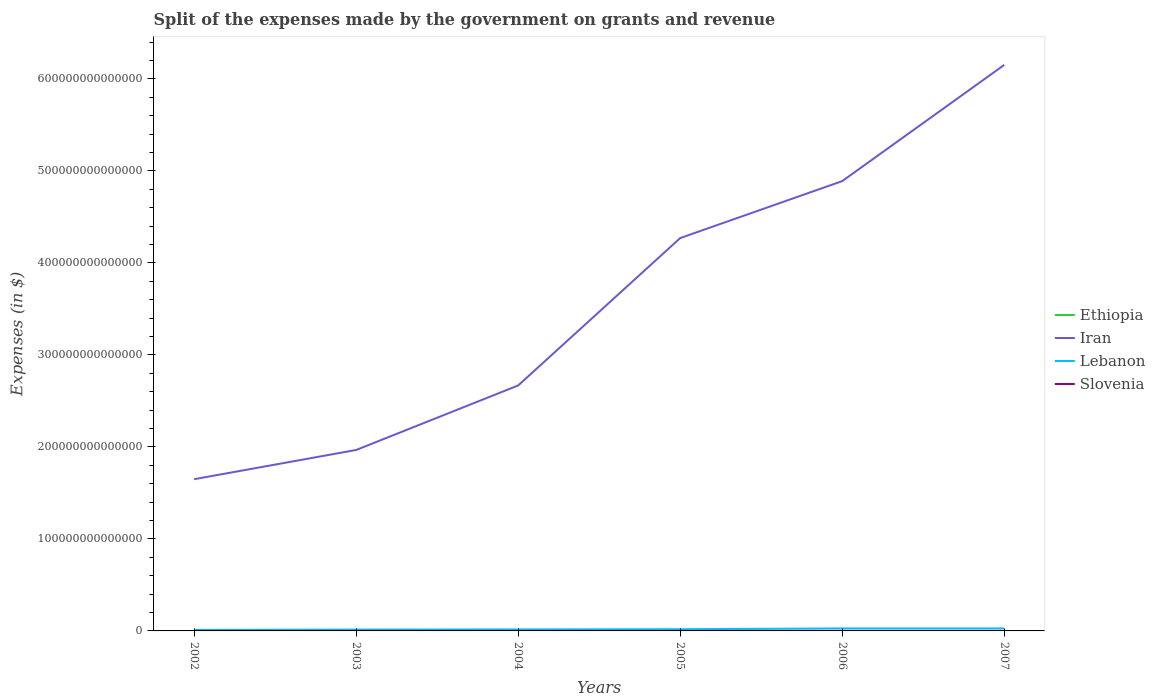Across all years, what is the maximum expenses made by the government on grants and revenue in Ethiopia?
Offer a very short reply. 2.69e+09. What is the total expenses made by the government on grants and revenue in Iran in the graph?
Offer a terse response. -2.62e+14. What is the difference between the highest and the second highest expenses made by the government on grants and revenue in Lebanon?
Your response must be concise. 1.57e+12. What is the difference between the highest and the lowest expenses made by the government on grants and revenue in Iran?
Provide a succinct answer. 3. Is the expenses made by the government on grants and revenue in Ethiopia strictly greater than the expenses made by the government on grants and revenue in Lebanon over the years?
Give a very brief answer. Yes. How many lines are there?
Keep it short and to the point. 4. What is the difference between two consecutive major ticks on the Y-axis?
Provide a short and direct response. 1.00e+14. Does the graph contain any zero values?
Your response must be concise. No. How are the legend labels stacked?
Keep it short and to the point. Vertical. What is the title of the graph?
Offer a very short reply. Split of the expenses made by the government on grants and revenue. What is the label or title of the Y-axis?
Make the answer very short. Expenses (in $). What is the Expenses (in $) in Ethiopia in 2002?
Ensure brevity in your answer.  3.36e+09. What is the Expenses (in $) of Iran in 2002?
Provide a short and direct response. 1.65e+14. What is the Expenses (in $) of Lebanon in 2002?
Your answer should be very brief. 1.14e+12. What is the Expenses (in $) in Slovenia in 2002?
Ensure brevity in your answer.  8.19e+08. What is the Expenses (in $) of Ethiopia in 2003?
Offer a terse response. 4.88e+09. What is the Expenses (in $) in Iran in 2003?
Provide a succinct answer. 1.97e+14. What is the Expenses (in $) of Lebanon in 2003?
Your answer should be very brief. 1.45e+12. What is the Expenses (in $) in Slovenia in 2003?
Provide a short and direct response. 8.59e+08. What is the Expenses (in $) in Ethiopia in 2004?
Offer a terse response. 7.63e+09. What is the Expenses (in $) of Iran in 2004?
Provide a succinct answer. 2.67e+14. What is the Expenses (in $) of Lebanon in 2004?
Your answer should be compact. 1.65e+12. What is the Expenses (in $) of Slovenia in 2004?
Offer a terse response. 1.04e+09. What is the Expenses (in $) of Ethiopia in 2005?
Offer a terse response. 7.71e+09. What is the Expenses (in $) of Iran in 2005?
Ensure brevity in your answer.  4.27e+14. What is the Expenses (in $) of Lebanon in 2005?
Give a very brief answer. 1.85e+12. What is the Expenses (in $) of Slovenia in 2005?
Give a very brief answer. 1.15e+09. What is the Expenses (in $) in Ethiopia in 2006?
Your answer should be compact. 2.69e+09. What is the Expenses (in $) in Iran in 2006?
Provide a succinct answer. 4.89e+14. What is the Expenses (in $) of Lebanon in 2006?
Ensure brevity in your answer.  2.71e+12. What is the Expenses (in $) in Slovenia in 2006?
Offer a terse response. 1.16e+09. What is the Expenses (in $) in Ethiopia in 2007?
Ensure brevity in your answer.  3.34e+09. What is the Expenses (in $) in Iran in 2007?
Provide a succinct answer. 6.15e+14. What is the Expenses (in $) of Lebanon in 2007?
Make the answer very short. 2.72e+12. What is the Expenses (in $) of Slovenia in 2007?
Provide a short and direct response. 1.28e+09. Across all years, what is the maximum Expenses (in $) of Ethiopia?
Offer a very short reply. 7.71e+09. Across all years, what is the maximum Expenses (in $) in Iran?
Offer a very short reply. 6.15e+14. Across all years, what is the maximum Expenses (in $) in Lebanon?
Offer a terse response. 2.72e+12. Across all years, what is the maximum Expenses (in $) of Slovenia?
Offer a terse response. 1.28e+09. Across all years, what is the minimum Expenses (in $) of Ethiopia?
Make the answer very short. 2.69e+09. Across all years, what is the minimum Expenses (in $) in Iran?
Provide a succinct answer. 1.65e+14. Across all years, what is the minimum Expenses (in $) in Lebanon?
Your answer should be very brief. 1.14e+12. Across all years, what is the minimum Expenses (in $) of Slovenia?
Give a very brief answer. 8.19e+08. What is the total Expenses (in $) of Ethiopia in the graph?
Keep it short and to the point. 2.96e+1. What is the total Expenses (in $) of Iran in the graph?
Keep it short and to the point. 2.16e+15. What is the total Expenses (in $) in Lebanon in the graph?
Provide a succinct answer. 1.15e+13. What is the total Expenses (in $) in Slovenia in the graph?
Your answer should be compact. 6.30e+09. What is the difference between the Expenses (in $) in Ethiopia in 2002 and that in 2003?
Keep it short and to the point. -1.51e+09. What is the difference between the Expenses (in $) of Iran in 2002 and that in 2003?
Keep it short and to the point. -3.18e+13. What is the difference between the Expenses (in $) of Lebanon in 2002 and that in 2003?
Keep it short and to the point. -3.08e+11. What is the difference between the Expenses (in $) in Slovenia in 2002 and that in 2003?
Provide a short and direct response. -3.99e+07. What is the difference between the Expenses (in $) of Ethiopia in 2002 and that in 2004?
Your answer should be very brief. -4.27e+09. What is the difference between the Expenses (in $) of Iran in 2002 and that in 2004?
Make the answer very short. -1.02e+14. What is the difference between the Expenses (in $) of Lebanon in 2002 and that in 2004?
Make the answer very short. -5.04e+11. What is the difference between the Expenses (in $) in Slovenia in 2002 and that in 2004?
Provide a succinct answer. -2.19e+08. What is the difference between the Expenses (in $) in Ethiopia in 2002 and that in 2005?
Make the answer very short. -4.35e+09. What is the difference between the Expenses (in $) in Iran in 2002 and that in 2005?
Your answer should be compact. -2.62e+14. What is the difference between the Expenses (in $) of Lebanon in 2002 and that in 2005?
Provide a succinct answer. -7.08e+11. What is the difference between the Expenses (in $) in Slovenia in 2002 and that in 2005?
Offer a very short reply. -3.29e+08. What is the difference between the Expenses (in $) of Ethiopia in 2002 and that in 2006?
Your answer should be compact. 6.76e+08. What is the difference between the Expenses (in $) of Iran in 2002 and that in 2006?
Make the answer very short. -3.24e+14. What is the difference between the Expenses (in $) in Lebanon in 2002 and that in 2006?
Your response must be concise. -1.57e+12. What is the difference between the Expenses (in $) of Slovenia in 2002 and that in 2006?
Your response must be concise. -3.39e+08. What is the difference between the Expenses (in $) in Ethiopia in 2002 and that in 2007?
Ensure brevity in your answer.  2.33e+07. What is the difference between the Expenses (in $) in Iran in 2002 and that in 2007?
Offer a very short reply. -4.50e+14. What is the difference between the Expenses (in $) in Lebanon in 2002 and that in 2007?
Your response must be concise. -1.57e+12. What is the difference between the Expenses (in $) of Slovenia in 2002 and that in 2007?
Make the answer very short. -4.64e+08. What is the difference between the Expenses (in $) of Ethiopia in 2003 and that in 2004?
Provide a succinct answer. -2.76e+09. What is the difference between the Expenses (in $) of Iran in 2003 and that in 2004?
Keep it short and to the point. -7.01e+13. What is the difference between the Expenses (in $) in Lebanon in 2003 and that in 2004?
Provide a succinct answer. -1.96e+11. What is the difference between the Expenses (in $) of Slovenia in 2003 and that in 2004?
Provide a succinct answer. -1.79e+08. What is the difference between the Expenses (in $) in Ethiopia in 2003 and that in 2005?
Keep it short and to the point. -2.84e+09. What is the difference between the Expenses (in $) in Iran in 2003 and that in 2005?
Make the answer very short. -2.30e+14. What is the difference between the Expenses (in $) of Lebanon in 2003 and that in 2005?
Give a very brief answer. -4.00e+11. What is the difference between the Expenses (in $) in Slovenia in 2003 and that in 2005?
Your response must be concise. -2.90e+08. What is the difference between the Expenses (in $) of Ethiopia in 2003 and that in 2006?
Ensure brevity in your answer.  2.19e+09. What is the difference between the Expenses (in $) in Iran in 2003 and that in 2006?
Give a very brief answer. -2.92e+14. What is the difference between the Expenses (in $) in Lebanon in 2003 and that in 2006?
Provide a short and direct response. -1.26e+12. What is the difference between the Expenses (in $) of Slovenia in 2003 and that in 2006?
Provide a short and direct response. -2.99e+08. What is the difference between the Expenses (in $) of Ethiopia in 2003 and that in 2007?
Offer a terse response. 1.54e+09. What is the difference between the Expenses (in $) of Iran in 2003 and that in 2007?
Give a very brief answer. -4.19e+14. What is the difference between the Expenses (in $) of Lebanon in 2003 and that in 2007?
Ensure brevity in your answer.  -1.27e+12. What is the difference between the Expenses (in $) of Slovenia in 2003 and that in 2007?
Give a very brief answer. -4.24e+08. What is the difference between the Expenses (in $) in Ethiopia in 2004 and that in 2005?
Provide a short and direct response. -7.96e+07. What is the difference between the Expenses (in $) of Iran in 2004 and that in 2005?
Keep it short and to the point. -1.60e+14. What is the difference between the Expenses (in $) in Lebanon in 2004 and that in 2005?
Offer a terse response. -2.04e+11. What is the difference between the Expenses (in $) of Slovenia in 2004 and that in 2005?
Give a very brief answer. -1.10e+08. What is the difference between the Expenses (in $) of Ethiopia in 2004 and that in 2006?
Give a very brief answer. 4.95e+09. What is the difference between the Expenses (in $) of Iran in 2004 and that in 2006?
Offer a terse response. -2.22e+14. What is the difference between the Expenses (in $) in Lebanon in 2004 and that in 2006?
Your answer should be compact. -1.06e+12. What is the difference between the Expenses (in $) in Slovenia in 2004 and that in 2006?
Your answer should be very brief. -1.20e+08. What is the difference between the Expenses (in $) of Ethiopia in 2004 and that in 2007?
Give a very brief answer. 4.29e+09. What is the difference between the Expenses (in $) in Iran in 2004 and that in 2007?
Provide a succinct answer. -3.48e+14. What is the difference between the Expenses (in $) in Lebanon in 2004 and that in 2007?
Offer a very short reply. -1.07e+12. What is the difference between the Expenses (in $) in Slovenia in 2004 and that in 2007?
Your answer should be very brief. -2.45e+08. What is the difference between the Expenses (in $) in Ethiopia in 2005 and that in 2006?
Offer a very short reply. 5.03e+09. What is the difference between the Expenses (in $) in Iran in 2005 and that in 2006?
Ensure brevity in your answer.  -6.19e+13. What is the difference between the Expenses (in $) in Lebanon in 2005 and that in 2006?
Give a very brief answer. -8.58e+11. What is the difference between the Expenses (in $) of Slovenia in 2005 and that in 2006?
Make the answer very short. -9.36e+06. What is the difference between the Expenses (in $) in Ethiopia in 2005 and that in 2007?
Your answer should be compact. 4.37e+09. What is the difference between the Expenses (in $) in Iran in 2005 and that in 2007?
Your answer should be very brief. -1.88e+14. What is the difference between the Expenses (in $) in Lebanon in 2005 and that in 2007?
Offer a very short reply. -8.66e+11. What is the difference between the Expenses (in $) of Slovenia in 2005 and that in 2007?
Offer a terse response. -1.35e+08. What is the difference between the Expenses (in $) in Ethiopia in 2006 and that in 2007?
Offer a terse response. -6.53e+08. What is the difference between the Expenses (in $) in Iran in 2006 and that in 2007?
Keep it short and to the point. -1.26e+14. What is the difference between the Expenses (in $) of Lebanon in 2006 and that in 2007?
Your answer should be very brief. -8.00e+09. What is the difference between the Expenses (in $) in Slovenia in 2006 and that in 2007?
Keep it short and to the point. -1.25e+08. What is the difference between the Expenses (in $) in Ethiopia in 2002 and the Expenses (in $) in Iran in 2003?
Give a very brief answer. -1.97e+14. What is the difference between the Expenses (in $) in Ethiopia in 2002 and the Expenses (in $) in Lebanon in 2003?
Provide a succinct answer. -1.45e+12. What is the difference between the Expenses (in $) in Ethiopia in 2002 and the Expenses (in $) in Slovenia in 2003?
Offer a terse response. 2.50e+09. What is the difference between the Expenses (in $) of Iran in 2002 and the Expenses (in $) of Lebanon in 2003?
Keep it short and to the point. 1.63e+14. What is the difference between the Expenses (in $) of Iran in 2002 and the Expenses (in $) of Slovenia in 2003?
Give a very brief answer. 1.65e+14. What is the difference between the Expenses (in $) in Lebanon in 2002 and the Expenses (in $) in Slovenia in 2003?
Your answer should be very brief. 1.14e+12. What is the difference between the Expenses (in $) of Ethiopia in 2002 and the Expenses (in $) of Iran in 2004?
Make the answer very short. -2.67e+14. What is the difference between the Expenses (in $) in Ethiopia in 2002 and the Expenses (in $) in Lebanon in 2004?
Give a very brief answer. -1.65e+12. What is the difference between the Expenses (in $) in Ethiopia in 2002 and the Expenses (in $) in Slovenia in 2004?
Offer a very short reply. 2.32e+09. What is the difference between the Expenses (in $) in Iran in 2002 and the Expenses (in $) in Lebanon in 2004?
Ensure brevity in your answer.  1.63e+14. What is the difference between the Expenses (in $) in Iran in 2002 and the Expenses (in $) in Slovenia in 2004?
Give a very brief answer. 1.65e+14. What is the difference between the Expenses (in $) in Lebanon in 2002 and the Expenses (in $) in Slovenia in 2004?
Offer a very short reply. 1.14e+12. What is the difference between the Expenses (in $) of Ethiopia in 2002 and the Expenses (in $) of Iran in 2005?
Your answer should be very brief. -4.27e+14. What is the difference between the Expenses (in $) of Ethiopia in 2002 and the Expenses (in $) of Lebanon in 2005?
Make the answer very short. -1.85e+12. What is the difference between the Expenses (in $) in Ethiopia in 2002 and the Expenses (in $) in Slovenia in 2005?
Your answer should be compact. 2.21e+09. What is the difference between the Expenses (in $) in Iran in 2002 and the Expenses (in $) in Lebanon in 2005?
Your response must be concise. 1.63e+14. What is the difference between the Expenses (in $) of Iran in 2002 and the Expenses (in $) of Slovenia in 2005?
Offer a terse response. 1.65e+14. What is the difference between the Expenses (in $) of Lebanon in 2002 and the Expenses (in $) of Slovenia in 2005?
Your answer should be compact. 1.14e+12. What is the difference between the Expenses (in $) in Ethiopia in 2002 and the Expenses (in $) in Iran in 2006?
Your answer should be very brief. -4.89e+14. What is the difference between the Expenses (in $) of Ethiopia in 2002 and the Expenses (in $) of Lebanon in 2006?
Give a very brief answer. -2.71e+12. What is the difference between the Expenses (in $) in Ethiopia in 2002 and the Expenses (in $) in Slovenia in 2006?
Make the answer very short. 2.20e+09. What is the difference between the Expenses (in $) of Iran in 2002 and the Expenses (in $) of Lebanon in 2006?
Offer a terse response. 1.62e+14. What is the difference between the Expenses (in $) of Iran in 2002 and the Expenses (in $) of Slovenia in 2006?
Ensure brevity in your answer.  1.65e+14. What is the difference between the Expenses (in $) of Lebanon in 2002 and the Expenses (in $) of Slovenia in 2006?
Keep it short and to the point. 1.14e+12. What is the difference between the Expenses (in $) in Ethiopia in 2002 and the Expenses (in $) in Iran in 2007?
Give a very brief answer. -6.15e+14. What is the difference between the Expenses (in $) in Ethiopia in 2002 and the Expenses (in $) in Lebanon in 2007?
Offer a very short reply. -2.72e+12. What is the difference between the Expenses (in $) of Ethiopia in 2002 and the Expenses (in $) of Slovenia in 2007?
Your answer should be compact. 2.08e+09. What is the difference between the Expenses (in $) in Iran in 2002 and the Expenses (in $) in Lebanon in 2007?
Keep it short and to the point. 1.62e+14. What is the difference between the Expenses (in $) of Iran in 2002 and the Expenses (in $) of Slovenia in 2007?
Make the answer very short. 1.65e+14. What is the difference between the Expenses (in $) of Lebanon in 2002 and the Expenses (in $) of Slovenia in 2007?
Provide a short and direct response. 1.14e+12. What is the difference between the Expenses (in $) of Ethiopia in 2003 and the Expenses (in $) of Iran in 2004?
Your response must be concise. -2.67e+14. What is the difference between the Expenses (in $) of Ethiopia in 2003 and the Expenses (in $) of Lebanon in 2004?
Your answer should be very brief. -1.64e+12. What is the difference between the Expenses (in $) of Ethiopia in 2003 and the Expenses (in $) of Slovenia in 2004?
Ensure brevity in your answer.  3.84e+09. What is the difference between the Expenses (in $) of Iran in 2003 and the Expenses (in $) of Lebanon in 2004?
Offer a terse response. 1.95e+14. What is the difference between the Expenses (in $) of Iran in 2003 and the Expenses (in $) of Slovenia in 2004?
Provide a succinct answer. 1.97e+14. What is the difference between the Expenses (in $) of Lebanon in 2003 and the Expenses (in $) of Slovenia in 2004?
Ensure brevity in your answer.  1.45e+12. What is the difference between the Expenses (in $) in Ethiopia in 2003 and the Expenses (in $) in Iran in 2005?
Your answer should be very brief. -4.27e+14. What is the difference between the Expenses (in $) of Ethiopia in 2003 and the Expenses (in $) of Lebanon in 2005?
Your answer should be very brief. -1.85e+12. What is the difference between the Expenses (in $) in Ethiopia in 2003 and the Expenses (in $) in Slovenia in 2005?
Offer a very short reply. 3.73e+09. What is the difference between the Expenses (in $) of Iran in 2003 and the Expenses (in $) of Lebanon in 2005?
Your answer should be compact. 1.95e+14. What is the difference between the Expenses (in $) in Iran in 2003 and the Expenses (in $) in Slovenia in 2005?
Offer a very short reply. 1.97e+14. What is the difference between the Expenses (in $) of Lebanon in 2003 and the Expenses (in $) of Slovenia in 2005?
Ensure brevity in your answer.  1.45e+12. What is the difference between the Expenses (in $) of Ethiopia in 2003 and the Expenses (in $) of Iran in 2006?
Offer a very short reply. -4.89e+14. What is the difference between the Expenses (in $) in Ethiopia in 2003 and the Expenses (in $) in Lebanon in 2006?
Keep it short and to the point. -2.71e+12. What is the difference between the Expenses (in $) of Ethiopia in 2003 and the Expenses (in $) of Slovenia in 2006?
Give a very brief answer. 3.72e+09. What is the difference between the Expenses (in $) of Iran in 2003 and the Expenses (in $) of Lebanon in 2006?
Offer a terse response. 1.94e+14. What is the difference between the Expenses (in $) of Iran in 2003 and the Expenses (in $) of Slovenia in 2006?
Ensure brevity in your answer.  1.97e+14. What is the difference between the Expenses (in $) in Lebanon in 2003 and the Expenses (in $) in Slovenia in 2006?
Make the answer very short. 1.45e+12. What is the difference between the Expenses (in $) of Ethiopia in 2003 and the Expenses (in $) of Iran in 2007?
Your answer should be very brief. -6.15e+14. What is the difference between the Expenses (in $) of Ethiopia in 2003 and the Expenses (in $) of Lebanon in 2007?
Offer a very short reply. -2.71e+12. What is the difference between the Expenses (in $) in Ethiopia in 2003 and the Expenses (in $) in Slovenia in 2007?
Give a very brief answer. 3.59e+09. What is the difference between the Expenses (in $) of Iran in 2003 and the Expenses (in $) of Lebanon in 2007?
Offer a terse response. 1.94e+14. What is the difference between the Expenses (in $) of Iran in 2003 and the Expenses (in $) of Slovenia in 2007?
Ensure brevity in your answer.  1.97e+14. What is the difference between the Expenses (in $) of Lebanon in 2003 and the Expenses (in $) of Slovenia in 2007?
Your answer should be very brief. 1.45e+12. What is the difference between the Expenses (in $) in Ethiopia in 2004 and the Expenses (in $) in Iran in 2005?
Your answer should be very brief. -4.27e+14. What is the difference between the Expenses (in $) in Ethiopia in 2004 and the Expenses (in $) in Lebanon in 2005?
Give a very brief answer. -1.85e+12. What is the difference between the Expenses (in $) of Ethiopia in 2004 and the Expenses (in $) of Slovenia in 2005?
Ensure brevity in your answer.  6.48e+09. What is the difference between the Expenses (in $) of Iran in 2004 and the Expenses (in $) of Lebanon in 2005?
Offer a very short reply. 2.65e+14. What is the difference between the Expenses (in $) in Iran in 2004 and the Expenses (in $) in Slovenia in 2005?
Make the answer very short. 2.67e+14. What is the difference between the Expenses (in $) in Lebanon in 2004 and the Expenses (in $) in Slovenia in 2005?
Your answer should be very brief. 1.65e+12. What is the difference between the Expenses (in $) in Ethiopia in 2004 and the Expenses (in $) in Iran in 2006?
Make the answer very short. -4.89e+14. What is the difference between the Expenses (in $) of Ethiopia in 2004 and the Expenses (in $) of Lebanon in 2006?
Your answer should be very brief. -2.70e+12. What is the difference between the Expenses (in $) of Ethiopia in 2004 and the Expenses (in $) of Slovenia in 2006?
Make the answer very short. 6.48e+09. What is the difference between the Expenses (in $) in Iran in 2004 and the Expenses (in $) in Lebanon in 2006?
Provide a succinct answer. 2.64e+14. What is the difference between the Expenses (in $) in Iran in 2004 and the Expenses (in $) in Slovenia in 2006?
Give a very brief answer. 2.67e+14. What is the difference between the Expenses (in $) in Lebanon in 2004 and the Expenses (in $) in Slovenia in 2006?
Your response must be concise. 1.65e+12. What is the difference between the Expenses (in $) in Ethiopia in 2004 and the Expenses (in $) in Iran in 2007?
Provide a succinct answer. -6.15e+14. What is the difference between the Expenses (in $) in Ethiopia in 2004 and the Expenses (in $) in Lebanon in 2007?
Ensure brevity in your answer.  -2.71e+12. What is the difference between the Expenses (in $) of Ethiopia in 2004 and the Expenses (in $) of Slovenia in 2007?
Your answer should be very brief. 6.35e+09. What is the difference between the Expenses (in $) in Iran in 2004 and the Expenses (in $) in Lebanon in 2007?
Keep it short and to the point. 2.64e+14. What is the difference between the Expenses (in $) in Iran in 2004 and the Expenses (in $) in Slovenia in 2007?
Keep it short and to the point. 2.67e+14. What is the difference between the Expenses (in $) of Lebanon in 2004 and the Expenses (in $) of Slovenia in 2007?
Ensure brevity in your answer.  1.65e+12. What is the difference between the Expenses (in $) of Ethiopia in 2005 and the Expenses (in $) of Iran in 2006?
Offer a terse response. -4.89e+14. What is the difference between the Expenses (in $) of Ethiopia in 2005 and the Expenses (in $) of Lebanon in 2006?
Offer a very short reply. -2.70e+12. What is the difference between the Expenses (in $) in Ethiopia in 2005 and the Expenses (in $) in Slovenia in 2006?
Provide a short and direct response. 6.55e+09. What is the difference between the Expenses (in $) of Iran in 2005 and the Expenses (in $) of Lebanon in 2006?
Make the answer very short. 4.24e+14. What is the difference between the Expenses (in $) in Iran in 2005 and the Expenses (in $) in Slovenia in 2006?
Provide a succinct answer. 4.27e+14. What is the difference between the Expenses (in $) of Lebanon in 2005 and the Expenses (in $) of Slovenia in 2006?
Your answer should be compact. 1.85e+12. What is the difference between the Expenses (in $) in Ethiopia in 2005 and the Expenses (in $) in Iran in 2007?
Provide a short and direct response. -6.15e+14. What is the difference between the Expenses (in $) of Ethiopia in 2005 and the Expenses (in $) of Lebanon in 2007?
Your response must be concise. -2.71e+12. What is the difference between the Expenses (in $) of Ethiopia in 2005 and the Expenses (in $) of Slovenia in 2007?
Provide a succinct answer. 6.43e+09. What is the difference between the Expenses (in $) in Iran in 2005 and the Expenses (in $) in Lebanon in 2007?
Offer a terse response. 4.24e+14. What is the difference between the Expenses (in $) in Iran in 2005 and the Expenses (in $) in Slovenia in 2007?
Make the answer very short. 4.27e+14. What is the difference between the Expenses (in $) in Lebanon in 2005 and the Expenses (in $) in Slovenia in 2007?
Ensure brevity in your answer.  1.85e+12. What is the difference between the Expenses (in $) in Ethiopia in 2006 and the Expenses (in $) in Iran in 2007?
Offer a terse response. -6.15e+14. What is the difference between the Expenses (in $) of Ethiopia in 2006 and the Expenses (in $) of Lebanon in 2007?
Offer a terse response. -2.72e+12. What is the difference between the Expenses (in $) of Ethiopia in 2006 and the Expenses (in $) of Slovenia in 2007?
Offer a very short reply. 1.40e+09. What is the difference between the Expenses (in $) in Iran in 2006 and the Expenses (in $) in Lebanon in 2007?
Offer a very short reply. 4.86e+14. What is the difference between the Expenses (in $) in Iran in 2006 and the Expenses (in $) in Slovenia in 2007?
Your answer should be compact. 4.89e+14. What is the difference between the Expenses (in $) in Lebanon in 2006 and the Expenses (in $) in Slovenia in 2007?
Provide a short and direct response. 2.71e+12. What is the average Expenses (in $) of Ethiopia per year?
Offer a terse response. 4.93e+09. What is the average Expenses (in $) in Iran per year?
Your answer should be compact. 3.60e+14. What is the average Expenses (in $) in Lebanon per year?
Offer a very short reply. 1.92e+12. What is the average Expenses (in $) of Slovenia per year?
Give a very brief answer. 1.05e+09. In the year 2002, what is the difference between the Expenses (in $) of Ethiopia and Expenses (in $) of Iran?
Provide a short and direct response. -1.65e+14. In the year 2002, what is the difference between the Expenses (in $) of Ethiopia and Expenses (in $) of Lebanon?
Offer a very short reply. -1.14e+12. In the year 2002, what is the difference between the Expenses (in $) in Ethiopia and Expenses (in $) in Slovenia?
Your answer should be very brief. 2.54e+09. In the year 2002, what is the difference between the Expenses (in $) in Iran and Expenses (in $) in Lebanon?
Provide a short and direct response. 1.64e+14. In the year 2002, what is the difference between the Expenses (in $) in Iran and Expenses (in $) in Slovenia?
Your answer should be very brief. 1.65e+14. In the year 2002, what is the difference between the Expenses (in $) in Lebanon and Expenses (in $) in Slovenia?
Offer a terse response. 1.14e+12. In the year 2003, what is the difference between the Expenses (in $) in Ethiopia and Expenses (in $) in Iran?
Your answer should be compact. -1.97e+14. In the year 2003, what is the difference between the Expenses (in $) of Ethiopia and Expenses (in $) of Lebanon?
Provide a succinct answer. -1.45e+12. In the year 2003, what is the difference between the Expenses (in $) in Ethiopia and Expenses (in $) in Slovenia?
Keep it short and to the point. 4.02e+09. In the year 2003, what is the difference between the Expenses (in $) in Iran and Expenses (in $) in Lebanon?
Give a very brief answer. 1.95e+14. In the year 2003, what is the difference between the Expenses (in $) of Iran and Expenses (in $) of Slovenia?
Offer a very short reply. 1.97e+14. In the year 2003, what is the difference between the Expenses (in $) of Lebanon and Expenses (in $) of Slovenia?
Give a very brief answer. 1.45e+12. In the year 2004, what is the difference between the Expenses (in $) in Ethiopia and Expenses (in $) in Iran?
Your answer should be very brief. -2.67e+14. In the year 2004, what is the difference between the Expenses (in $) of Ethiopia and Expenses (in $) of Lebanon?
Provide a succinct answer. -1.64e+12. In the year 2004, what is the difference between the Expenses (in $) in Ethiopia and Expenses (in $) in Slovenia?
Offer a terse response. 6.60e+09. In the year 2004, what is the difference between the Expenses (in $) of Iran and Expenses (in $) of Lebanon?
Make the answer very short. 2.65e+14. In the year 2004, what is the difference between the Expenses (in $) of Iran and Expenses (in $) of Slovenia?
Offer a terse response. 2.67e+14. In the year 2004, what is the difference between the Expenses (in $) of Lebanon and Expenses (in $) of Slovenia?
Give a very brief answer. 1.65e+12. In the year 2005, what is the difference between the Expenses (in $) of Ethiopia and Expenses (in $) of Iran?
Keep it short and to the point. -4.27e+14. In the year 2005, what is the difference between the Expenses (in $) in Ethiopia and Expenses (in $) in Lebanon?
Your response must be concise. -1.85e+12. In the year 2005, what is the difference between the Expenses (in $) of Ethiopia and Expenses (in $) of Slovenia?
Offer a terse response. 6.56e+09. In the year 2005, what is the difference between the Expenses (in $) of Iran and Expenses (in $) of Lebanon?
Ensure brevity in your answer.  4.25e+14. In the year 2005, what is the difference between the Expenses (in $) of Iran and Expenses (in $) of Slovenia?
Give a very brief answer. 4.27e+14. In the year 2005, what is the difference between the Expenses (in $) of Lebanon and Expenses (in $) of Slovenia?
Keep it short and to the point. 1.85e+12. In the year 2006, what is the difference between the Expenses (in $) of Ethiopia and Expenses (in $) of Iran?
Offer a terse response. -4.89e+14. In the year 2006, what is the difference between the Expenses (in $) in Ethiopia and Expenses (in $) in Lebanon?
Offer a very short reply. -2.71e+12. In the year 2006, what is the difference between the Expenses (in $) of Ethiopia and Expenses (in $) of Slovenia?
Your answer should be very brief. 1.53e+09. In the year 2006, what is the difference between the Expenses (in $) in Iran and Expenses (in $) in Lebanon?
Provide a succinct answer. 4.86e+14. In the year 2006, what is the difference between the Expenses (in $) in Iran and Expenses (in $) in Slovenia?
Provide a succinct answer. 4.89e+14. In the year 2006, what is the difference between the Expenses (in $) in Lebanon and Expenses (in $) in Slovenia?
Provide a succinct answer. 2.71e+12. In the year 2007, what is the difference between the Expenses (in $) of Ethiopia and Expenses (in $) of Iran?
Your answer should be compact. -6.15e+14. In the year 2007, what is the difference between the Expenses (in $) of Ethiopia and Expenses (in $) of Lebanon?
Offer a very short reply. -2.72e+12. In the year 2007, what is the difference between the Expenses (in $) in Ethiopia and Expenses (in $) in Slovenia?
Your answer should be very brief. 2.06e+09. In the year 2007, what is the difference between the Expenses (in $) of Iran and Expenses (in $) of Lebanon?
Make the answer very short. 6.12e+14. In the year 2007, what is the difference between the Expenses (in $) of Iran and Expenses (in $) of Slovenia?
Give a very brief answer. 6.15e+14. In the year 2007, what is the difference between the Expenses (in $) in Lebanon and Expenses (in $) in Slovenia?
Provide a short and direct response. 2.72e+12. What is the ratio of the Expenses (in $) in Ethiopia in 2002 to that in 2003?
Your response must be concise. 0.69. What is the ratio of the Expenses (in $) in Iran in 2002 to that in 2003?
Your response must be concise. 0.84. What is the ratio of the Expenses (in $) in Lebanon in 2002 to that in 2003?
Give a very brief answer. 0.79. What is the ratio of the Expenses (in $) of Slovenia in 2002 to that in 2003?
Give a very brief answer. 0.95. What is the ratio of the Expenses (in $) of Ethiopia in 2002 to that in 2004?
Keep it short and to the point. 0.44. What is the ratio of the Expenses (in $) of Iran in 2002 to that in 2004?
Make the answer very short. 0.62. What is the ratio of the Expenses (in $) in Lebanon in 2002 to that in 2004?
Offer a very short reply. 0.69. What is the ratio of the Expenses (in $) of Slovenia in 2002 to that in 2004?
Your answer should be very brief. 0.79. What is the ratio of the Expenses (in $) in Ethiopia in 2002 to that in 2005?
Offer a terse response. 0.44. What is the ratio of the Expenses (in $) in Iran in 2002 to that in 2005?
Offer a very short reply. 0.39. What is the ratio of the Expenses (in $) in Lebanon in 2002 to that in 2005?
Your answer should be very brief. 0.62. What is the ratio of the Expenses (in $) in Slovenia in 2002 to that in 2005?
Ensure brevity in your answer.  0.71. What is the ratio of the Expenses (in $) in Ethiopia in 2002 to that in 2006?
Offer a terse response. 1.25. What is the ratio of the Expenses (in $) of Iran in 2002 to that in 2006?
Provide a succinct answer. 0.34. What is the ratio of the Expenses (in $) in Lebanon in 2002 to that in 2006?
Keep it short and to the point. 0.42. What is the ratio of the Expenses (in $) in Slovenia in 2002 to that in 2006?
Provide a succinct answer. 0.71. What is the ratio of the Expenses (in $) of Iran in 2002 to that in 2007?
Keep it short and to the point. 0.27. What is the ratio of the Expenses (in $) in Lebanon in 2002 to that in 2007?
Make the answer very short. 0.42. What is the ratio of the Expenses (in $) in Slovenia in 2002 to that in 2007?
Provide a short and direct response. 0.64. What is the ratio of the Expenses (in $) of Ethiopia in 2003 to that in 2004?
Give a very brief answer. 0.64. What is the ratio of the Expenses (in $) of Iran in 2003 to that in 2004?
Give a very brief answer. 0.74. What is the ratio of the Expenses (in $) in Lebanon in 2003 to that in 2004?
Make the answer very short. 0.88. What is the ratio of the Expenses (in $) in Slovenia in 2003 to that in 2004?
Your answer should be very brief. 0.83. What is the ratio of the Expenses (in $) of Ethiopia in 2003 to that in 2005?
Offer a very short reply. 0.63. What is the ratio of the Expenses (in $) of Iran in 2003 to that in 2005?
Make the answer very short. 0.46. What is the ratio of the Expenses (in $) in Lebanon in 2003 to that in 2005?
Your answer should be compact. 0.78. What is the ratio of the Expenses (in $) of Slovenia in 2003 to that in 2005?
Provide a short and direct response. 0.75. What is the ratio of the Expenses (in $) of Ethiopia in 2003 to that in 2006?
Provide a short and direct response. 1.82. What is the ratio of the Expenses (in $) of Iran in 2003 to that in 2006?
Make the answer very short. 0.4. What is the ratio of the Expenses (in $) in Lebanon in 2003 to that in 2006?
Keep it short and to the point. 0.54. What is the ratio of the Expenses (in $) of Slovenia in 2003 to that in 2006?
Your response must be concise. 0.74. What is the ratio of the Expenses (in $) of Ethiopia in 2003 to that in 2007?
Ensure brevity in your answer.  1.46. What is the ratio of the Expenses (in $) in Iran in 2003 to that in 2007?
Offer a terse response. 0.32. What is the ratio of the Expenses (in $) of Lebanon in 2003 to that in 2007?
Your answer should be compact. 0.53. What is the ratio of the Expenses (in $) in Slovenia in 2003 to that in 2007?
Your answer should be compact. 0.67. What is the ratio of the Expenses (in $) in Ethiopia in 2004 to that in 2005?
Offer a terse response. 0.99. What is the ratio of the Expenses (in $) of Iran in 2004 to that in 2005?
Ensure brevity in your answer.  0.62. What is the ratio of the Expenses (in $) in Lebanon in 2004 to that in 2005?
Your answer should be very brief. 0.89. What is the ratio of the Expenses (in $) in Slovenia in 2004 to that in 2005?
Your answer should be compact. 0.9. What is the ratio of the Expenses (in $) of Ethiopia in 2004 to that in 2006?
Offer a terse response. 2.84. What is the ratio of the Expenses (in $) of Iran in 2004 to that in 2006?
Offer a very short reply. 0.55. What is the ratio of the Expenses (in $) of Lebanon in 2004 to that in 2006?
Your answer should be very brief. 0.61. What is the ratio of the Expenses (in $) of Slovenia in 2004 to that in 2006?
Provide a succinct answer. 0.9. What is the ratio of the Expenses (in $) in Ethiopia in 2004 to that in 2007?
Make the answer very short. 2.29. What is the ratio of the Expenses (in $) of Iran in 2004 to that in 2007?
Keep it short and to the point. 0.43. What is the ratio of the Expenses (in $) in Lebanon in 2004 to that in 2007?
Your response must be concise. 0.61. What is the ratio of the Expenses (in $) of Slovenia in 2004 to that in 2007?
Your response must be concise. 0.81. What is the ratio of the Expenses (in $) of Ethiopia in 2005 to that in 2006?
Your answer should be compact. 2.87. What is the ratio of the Expenses (in $) of Iran in 2005 to that in 2006?
Your answer should be compact. 0.87. What is the ratio of the Expenses (in $) of Lebanon in 2005 to that in 2006?
Your answer should be very brief. 0.68. What is the ratio of the Expenses (in $) in Slovenia in 2005 to that in 2006?
Give a very brief answer. 0.99. What is the ratio of the Expenses (in $) of Ethiopia in 2005 to that in 2007?
Provide a succinct answer. 2.31. What is the ratio of the Expenses (in $) of Iran in 2005 to that in 2007?
Keep it short and to the point. 0.69. What is the ratio of the Expenses (in $) in Lebanon in 2005 to that in 2007?
Ensure brevity in your answer.  0.68. What is the ratio of the Expenses (in $) in Slovenia in 2005 to that in 2007?
Provide a short and direct response. 0.9. What is the ratio of the Expenses (in $) in Ethiopia in 2006 to that in 2007?
Offer a very short reply. 0.8. What is the ratio of the Expenses (in $) of Iran in 2006 to that in 2007?
Offer a terse response. 0.79. What is the ratio of the Expenses (in $) in Lebanon in 2006 to that in 2007?
Offer a terse response. 1. What is the ratio of the Expenses (in $) of Slovenia in 2006 to that in 2007?
Provide a succinct answer. 0.9. What is the difference between the highest and the second highest Expenses (in $) in Ethiopia?
Keep it short and to the point. 7.96e+07. What is the difference between the highest and the second highest Expenses (in $) of Iran?
Offer a very short reply. 1.26e+14. What is the difference between the highest and the second highest Expenses (in $) of Lebanon?
Your answer should be compact. 8.00e+09. What is the difference between the highest and the second highest Expenses (in $) in Slovenia?
Your response must be concise. 1.25e+08. What is the difference between the highest and the lowest Expenses (in $) in Ethiopia?
Provide a succinct answer. 5.03e+09. What is the difference between the highest and the lowest Expenses (in $) in Iran?
Ensure brevity in your answer.  4.50e+14. What is the difference between the highest and the lowest Expenses (in $) in Lebanon?
Keep it short and to the point. 1.57e+12. What is the difference between the highest and the lowest Expenses (in $) in Slovenia?
Provide a succinct answer. 4.64e+08. 